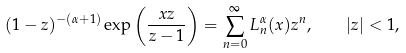<formula> <loc_0><loc_0><loc_500><loc_500>( 1 - z ) ^ { - ( \alpha + 1 ) } \exp \left ( \frac { x z } { z - 1 } \right ) = \sum _ { n = 0 } ^ { \infty } L _ { n } ^ { \alpha } ( x ) z ^ { n } , \quad | z | < 1 ,</formula> 